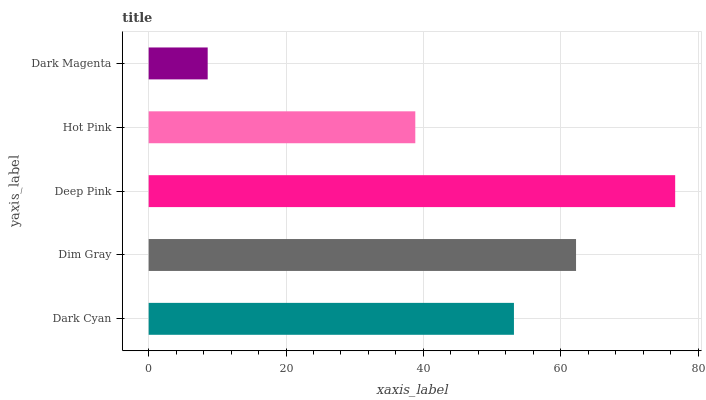Is Dark Magenta the minimum?
Answer yes or no. Yes. Is Deep Pink the maximum?
Answer yes or no. Yes. Is Dim Gray the minimum?
Answer yes or no. No. Is Dim Gray the maximum?
Answer yes or no. No. Is Dim Gray greater than Dark Cyan?
Answer yes or no. Yes. Is Dark Cyan less than Dim Gray?
Answer yes or no. Yes. Is Dark Cyan greater than Dim Gray?
Answer yes or no. No. Is Dim Gray less than Dark Cyan?
Answer yes or no. No. Is Dark Cyan the high median?
Answer yes or no. Yes. Is Dark Cyan the low median?
Answer yes or no. Yes. Is Hot Pink the high median?
Answer yes or no. No. Is Deep Pink the low median?
Answer yes or no. No. 